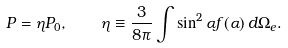Convert formula to latex. <formula><loc_0><loc_0><loc_500><loc_500>P = \eta P _ { 0 } , \quad \eta \equiv \frac { 3 } { 8 \pi } \int \sin ^ { 2 } { \alpha } f ( \alpha ) \, d \Omega _ { e } .</formula> 